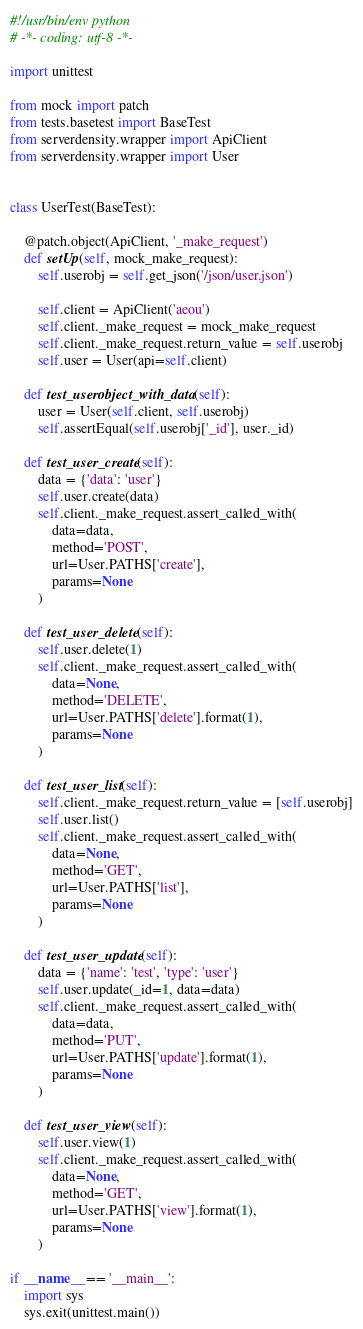<code> <loc_0><loc_0><loc_500><loc_500><_Python_>#!/usr/bin/env python
# -*- coding: utf-8 -*-

import unittest

from mock import patch
from tests.basetest import BaseTest
from serverdensity.wrapper import ApiClient
from serverdensity.wrapper import User


class UserTest(BaseTest):

    @patch.object(ApiClient, '_make_request')
    def setUp(self, mock_make_request):
        self.userobj = self.get_json('/json/user.json')

        self.client = ApiClient('aeou')
        self.client._make_request = mock_make_request
        self.client._make_request.return_value = self.userobj
        self.user = User(api=self.client)

    def test_userobject_with_data(self):
        user = User(self.client, self.userobj)
        self.assertEqual(self.userobj['_id'], user._id)

    def test_user_create(self):
        data = {'data': 'user'}
        self.user.create(data)
        self.client._make_request.assert_called_with(
            data=data,
            method='POST',
            url=User.PATHS['create'],
            params=None
        )

    def test_user_delete(self):
        self.user.delete(1)
        self.client._make_request.assert_called_with(
            data=None,
            method='DELETE',
            url=User.PATHS['delete'].format(1),
            params=None
        )

    def test_user_list(self):
        self.client._make_request.return_value = [self.userobj]
        self.user.list()
        self.client._make_request.assert_called_with(
            data=None,
            method='GET',
            url=User.PATHS['list'],
            params=None
        )

    def test_user_update(self):
        data = {'name': 'test', 'type': 'user'}
        self.user.update(_id=1, data=data)
        self.client._make_request.assert_called_with(
            data=data,
            method='PUT',
            url=User.PATHS['update'].format(1),
            params=None
        )

    def test_user_view(self):
        self.user.view(1)
        self.client._make_request.assert_called_with(
            data=None,
            method='GET',
            url=User.PATHS['view'].format(1),
            params=None
        )

if __name__ == '__main__':
    import sys
    sys.exit(unittest.main())
</code> 